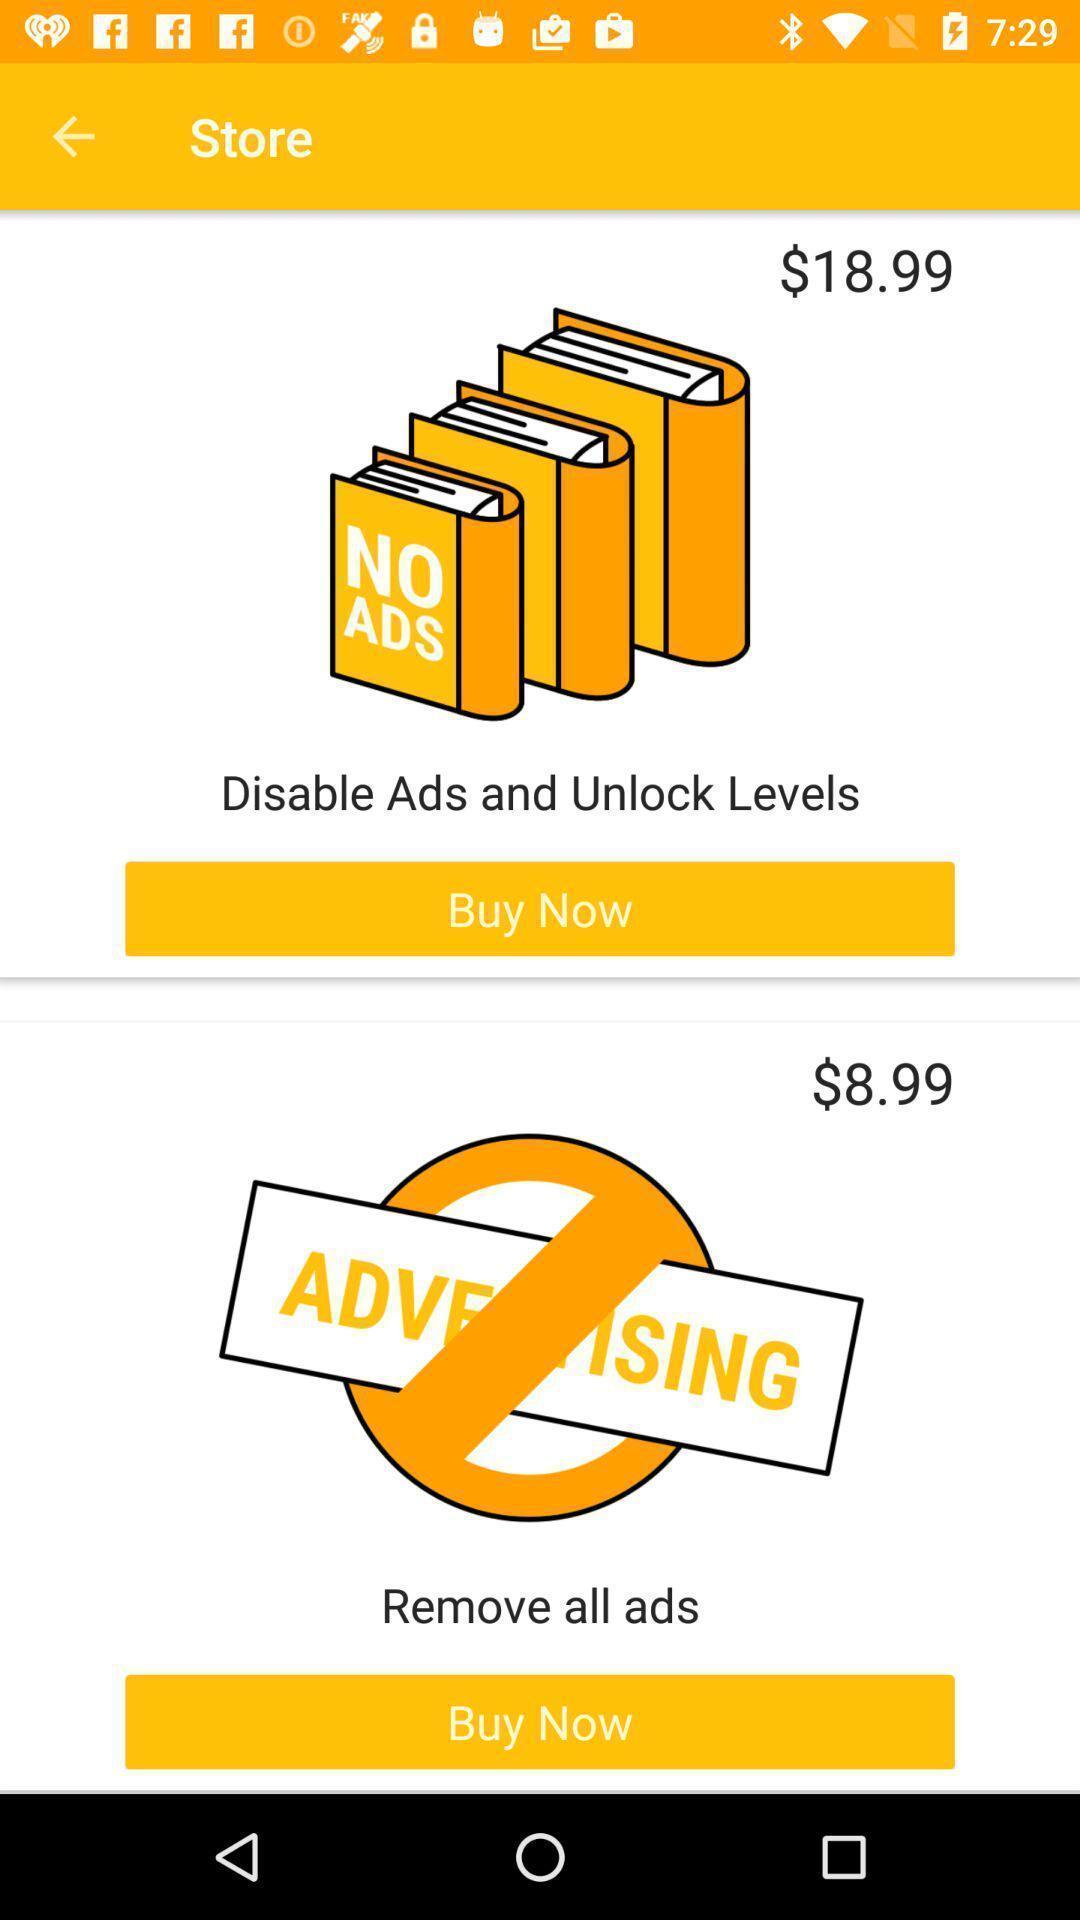Explain the elements present in this screenshot. Page showing about different products in store. 